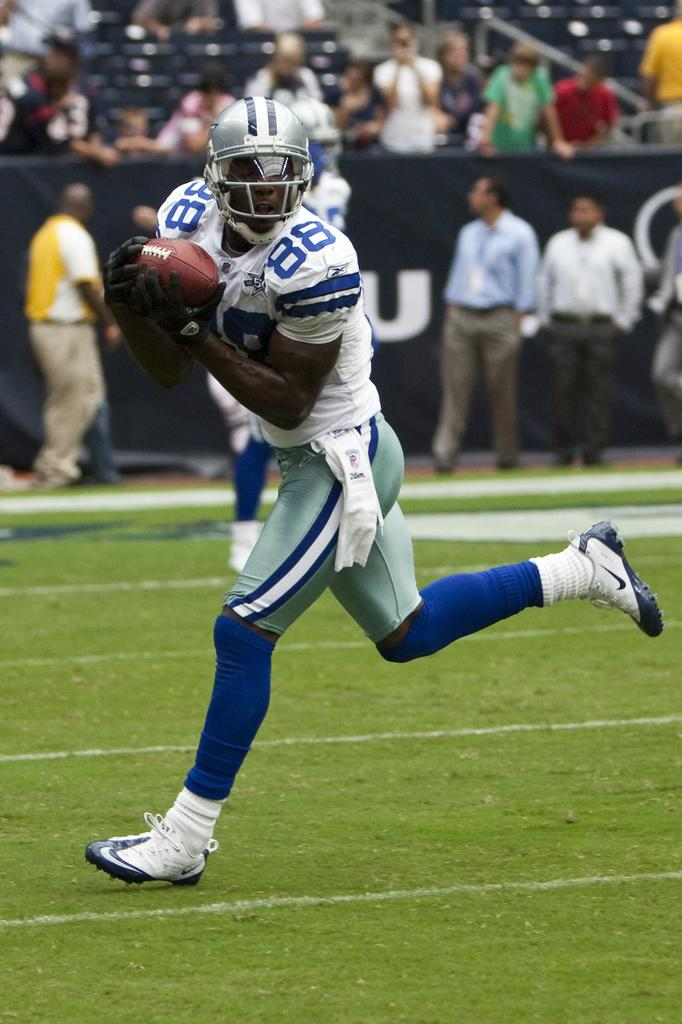What is the man in the image doing? The man is running in the image. What is the man holding while running? The man is holding a ball. Can you describe the other people in the image? There is a group of people in the image. What is hanging in the image? There is a banner in the image. What can be seen in the background of the image? Chairs are present in the background of the image. What type of air is being used by the man to run in the image? The man is running on the ground, so there is no specific type of air being used. Can you tell me where the church is located in the image? There is no church present in the image. 